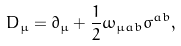Convert formula to latex. <formula><loc_0><loc_0><loc_500><loc_500>D _ { \mu } = \partial _ { \mu } + \frac { 1 } { 2 } \omega _ { \mu a b } \sigma ^ { a b } ,</formula> 